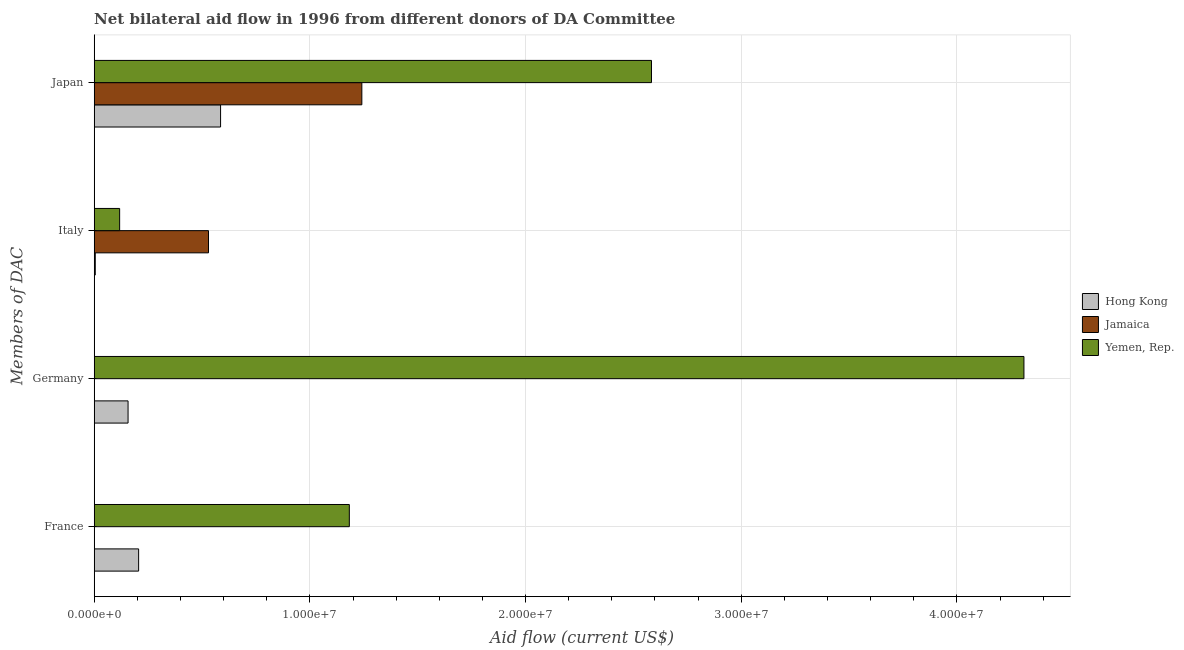How many bars are there on the 4th tick from the top?
Keep it short and to the point. 2. How many bars are there on the 1st tick from the bottom?
Ensure brevity in your answer.  2. What is the label of the 4th group of bars from the top?
Your answer should be compact. France. What is the amount of aid given by italy in Hong Kong?
Provide a succinct answer. 5.00e+04. Across all countries, what is the maximum amount of aid given by japan?
Give a very brief answer. 2.58e+07. Across all countries, what is the minimum amount of aid given by japan?
Your response must be concise. 5.86e+06. In which country was the amount of aid given by germany maximum?
Your response must be concise. Yemen, Rep. What is the total amount of aid given by germany in the graph?
Ensure brevity in your answer.  4.47e+07. What is the difference between the amount of aid given by italy in Yemen, Rep. and that in Hong Kong?
Provide a short and direct response. 1.13e+06. What is the difference between the amount of aid given by italy in Yemen, Rep. and the amount of aid given by germany in Jamaica?
Offer a terse response. 1.18e+06. What is the average amount of aid given by germany per country?
Your answer should be very brief. 1.49e+07. What is the difference between the amount of aid given by japan and amount of aid given by france in Hong Kong?
Your answer should be compact. 3.80e+06. In how many countries, is the amount of aid given by france greater than 42000000 US$?
Ensure brevity in your answer.  0. What is the ratio of the amount of aid given by japan in Yemen, Rep. to that in Hong Kong?
Provide a succinct answer. 4.41. Is the amount of aid given by italy in Jamaica less than that in Hong Kong?
Your answer should be compact. No. What is the difference between the highest and the lowest amount of aid given by italy?
Make the answer very short. 5.25e+06. In how many countries, is the amount of aid given by japan greater than the average amount of aid given by japan taken over all countries?
Ensure brevity in your answer.  1. Is the sum of the amount of aid given by japan in Yemen, Rep. and Jamaica greater than the maximum amount of aid given by italy across all countries?
Ensure brevity in your answer.  Yes. How many bars are there?
Ensure brevity in your answer.  10. Does the graph contain any zero values?
Make the answer very short. Yes. Where does the legend appear in the graph?
Your answer should be compact. Center right. What is the title of the graph?
Give a very brief answer. Net bilateral aid flow in 1996 from different donors of DA Committee. Does "Greenland" appear as one of the legend labels in the graph?
Provide a succinct answer. No. What is the label or title of the Y-axis?
Make the answer very short. Members of DAC. What is the Aid flow (current US$) in Hong Kong in France?
Offer a very short reply. 2.06e+06. What is the Aid flow (current US$) in Yemen, Rep. in France?
Offer a terse response. 1.18e+07. What is the Aid flow (current US$) of Hong Kong in Germany?
Keep it short and to the point. 1.57e+06. What is the Aid flow (current US$) in Yemen, Rep. in Germany?
Your answer should be compact. 4.31e+07. What is the Aid flow (current US$) of Jamaica in Italy?
Keep it short and to the point. 5.30e+06. What is the Aid flow (current US$) of Yemen, Rep. in Italy?
Provide a short and direct response. 1.18e+06. What is the Aid flow (current US$) in Hong Kong in Japan?
Ensure brevity in your answer.  5.86e+06. What is the Aid flow (current US$) of Jamaica in Japan?
Provide a succinct answer. 1.24e+07. What is the Aid flow (current US$) of Yemen, Rep. in Japan?
Your response must be concise. 2.58e+07. Across all Members of DAC, what is the maximum Aid flow (current US$) in Hong Kong?
Keep it short and to the point. 5.86e+06. Across all Members of DAC, what is the maximum Aid flow (current US$) in Jamaica?
Give a very brief answer. 1.24e+07. Across all Members of DAC, what is the maximum Aid flow (current US$) of Yemen, Rep.?
Provide a short and direct response. 4.31e+07. Across all Members of DAC, what is the minimum Aid flow (current US$) of Yemen, Rep.?
Your answer should be very brief. 1.18e+06. What is the total Aid flow (current US$) in Hong Kong in the graph?
Your response must be concise. 9.54e+06. What is the total Aid flow (current US$) in Jamaica in the graph?
Provide a succinct answer. 1.77e+07. What is the total Aid flow (current US$) of Yemen, Rep. in the graph?
Your answer should be very brief. 8.20e+07. What is the difference between the Aid flow (current US$) of Yemen, Rep. in France and that in Germany?
Keep it short and to the point. -3.13e+07. What is the difference between the Aid flow (current US$) of Hong Kong in France and that in Italy?
Offer a terse response. 2.01e+06. What is the difference between the Aid flow (current US$) of Yemen, Rep. in France and that in Italy?
Your answer should be very brief. 1.06e+07. What is the difference between the Aid flow (current US$) of Hong Kong in France and that in Japan?
Keep it short and to the point. -3.80e+06. What is the difference between the Aid flow (current US$) in Yemen, Rep. in France and that in Japan?
Keep it short and to the point. -1.40e+07. What is the difference between the Aid flow (current US$) of Hong Kong in Germany and that in Italy?
Provide a short and direct response. 1.52e+06. What is the difference between the Aid flow (current US$) of Yemen, Rep. in Germany and that in Italy?
Provide a succinct answer. 4.19e+07. What is the difference between the Aid flow (current US$) of Hong Kong in Germany and that in Japan?
Provide a short and direct response. -4.29e+06. What is the difference between the Aid flow (current US$) of Yemen, Rep. in Germany and that in Japan?
Make the answer very short. 1.73e+07. What is the difference between the Aid flow (current US$) of Hong Kong in Italy and that in Japan?
Provide a succinct answer. -5.81e+06. What is the difference between the Aid flow (current US$) in Jamaica in Italy and that in Japan?
Offer a very short reply. -7.11e+06. What is the difference between the Aid flow (current US$) of Yemen, Rep. in Italy and that in Japan?
Provide a succinct answer. -2.47e+07. What is the difference between the Aid flow (current US$) in Hong Kong in France and the Aid flow (current US$) in Yemen, Rep. in Germany?
Make the answer very short. -4.10e+07. What is the difference between the Aid flow (current US$) of Hong Kong in France and the Aid flow (current US$) of Jamaica in Italy?
Give a very brief answer. -3.24e+06. What is the difference between the Aid flow (current US$) of Hong Kong in France and the Aid flow (current US$) of Yemen, Rep. in Italy?
Offer a terse response. 8.80e+05. What is the difference between the Aid flow (current US$) in Hong Kong in France and the Aid flow (current US$) in Jamaica in Japan?
Provide a short and direct response. -1.04e+07. What is the difference between the Aid flow (current US$) of Hong Kong in France and the Aid flow (current US$) of Yemen, Rep. in Japan?
Your answer should be very brief. -2.38e+07. What is the difference between the Aid flow (current US$) of Hong Kong in Germany and the Aid flow (current US$) of Jamaica in Italy?
Keep it short and to the point. -3.73e+06. What is the difference between the Aid flow (current US$) of Hong Kong in Germany and the Aid flow (current US$) of Yemen, Rep. in Italy?
Provide a short and direct response. 3.90e+05. What is the difference between the Aid flow (current US$) in Hong Kong in Germany and the Aid flow (current US$) in Jamaica in Japan?
Make the answer very short. -1.08e+07. What is the difference between the Aid flow (current US$) of Hong Kong in Germany and the Aid flow (current US$) of Yemen, Rep. in Japan?
Provide a succinct answer. -2.43e+07. What is the difference between the Aid flow (current US$) in Hong Kong in Italy and the Aid flow (current US$) in Jamaica in Japan?
Provide a short and direct response. -1.24e+07. What is the difference between the Aid flow (current US$) of Hong Kong in Italy and the Aid flow (current US$) of Yemen, Rep. in Japan?
Keep it short and to the point. -2.58e+07. What is the difference between the Aid flow (current US$) in Jamaica in Italy and the Aid flow (current US$) in Yemen, Rep. in Japan?
Offer a very short reply. -2.05e+07. What is the average Aid flow (current US$) in Hong Kong per Members of DAC?
Your answer should be compact. 2.38e+06. What is the average Aid flow (current US$) of Jamaica per Members of DAC?
Your response must be concise. 4.43e+06. What is the average Aid flow (current US$) of Yemen, Rep. per Members of DAC?
Your answer should be very brief. 2.05e+07. What is the difference between the Aid flow (current US$) in Hong Kong and Aid flow (current US$) in Yemen, Rep. in France?
Provide a short and direct response. -9.77e+06. What is the difference between the Aid flow (current US$) of Hong Kong and Aid flow (current US$) of Yemen, Rep. in Germany?
Provide a short and direct response. -4.15e+07. What is the difference between the Aid flow (current US$) of Hong Kong and Aid flow (current US$) of Jamaica in Italy?
Your answer should be very brief. -5.25e+06. What is the difference between the Aid flow (current US$) in Hong Kong and Aid flow (current US$) in Yemen, Rep. in Italy?
Your answer should be compact. -1.13e+06. What is the difference between the Aid flow (current US$) of Jamaica and Aid flow (current US$) of Yemen, Rep. in Italy?
Make the answer very short. 4.12e+06. What is the difference between the Aid flow (current US$) in Hong Kong and Aid flow (current US$) in Jamaica in Japan?
Your answer should be compact. -6.55e+06. What is the difference between the Aid flow (current US$) of Hong Kong and Aid flow (current US$) of Yemen, Rep. in Japan?
Make the answer very short. -2.00e+07. What is the difference between the Aid flow (current US$) in Jamaica and Aid flow (current US$) in Yemen, Rep. in Japan?
Provide a succinct answer. -1.34e+07. What is the ratio of the Aid flow (current US$) in Hong Kong in France to that in Germany?
Give a very brief answer. 1.31. What is the ratio of the Aid flow (current US$) in Yemen, Rep. in France to that in Germany?
Keep it short and to the point. 0.27. What is the ratio of the Aid flow (current US$) in Hong Kong in France to that in Italy?
Offer a terse response. 41.2. What is the ratio of the Aid flow (current US$) of Yemen, Rep. in France to that in Italy?
Give a very brief answer. 10.03. What is the ratio of the Aid flow (current US$) in Hong Kong in France to that in Japan?
Keep it short and to the point. 0.35. What is the ratio of the Aid flow (current US$) in Yemen, Rep. in France to that in Japan?
Give a very brief answer. 0.46. What is the ratio of the Aid flow (current US$) of Hong Kong in Germany to that in Italy?
Give a very brief answer. 31.4. What is the ratio of the Aid flow (current US$) in Yemen, Rep. in Germany to that in Italy?
Your answer should be compact. 36.53. What is the ratio of the Aid flow (current US$) of Hong Kong in Germany to that in Japan?
Your answer should be compact. 0.27. What is the ratio of the Aid flow (current US$) of Yemen, Rep. in Germany to that in Japan?
Your response must be concise. 1.67. What is the ratio of the Aid flow (current US$) of Hong Kong in Italy to that in Japan?
Provide a succinct answer. 0.01. What is the ratio of the Aid flow (current US$) in Jamaica in Italy to that in Japan?
Provide a succinct answer. 0.43. What is the ratio of the Aid flow (current US$) in Yemen, Rep. in Italy to that in Japan?
Ensure brevity in your answer.  0.05. What is the difference between the highest and the second highest Aid flow (current US$) in Hong Kong?
Provide a succinct answer. 3.80e+06. What is the difference between the highest and the second highest Aid flow (current US$) of Yemen, Rep.?
Offer a very short reply. 1.73e+07. What is the difference between the highest and the lowest Aid flow (current US$) of Hong Kong?
Offer a terse response. 5.81e+06. What is the difference between the highest and the lowest Aid flow (current US$) in Jamaica?
Provide a short and direct response. 1.24e+07. What is the difference between the highest and the lowest Aid flow (current US$) in Yemen, Rep.?
Provide a succinct answer. 4.19e+07. 